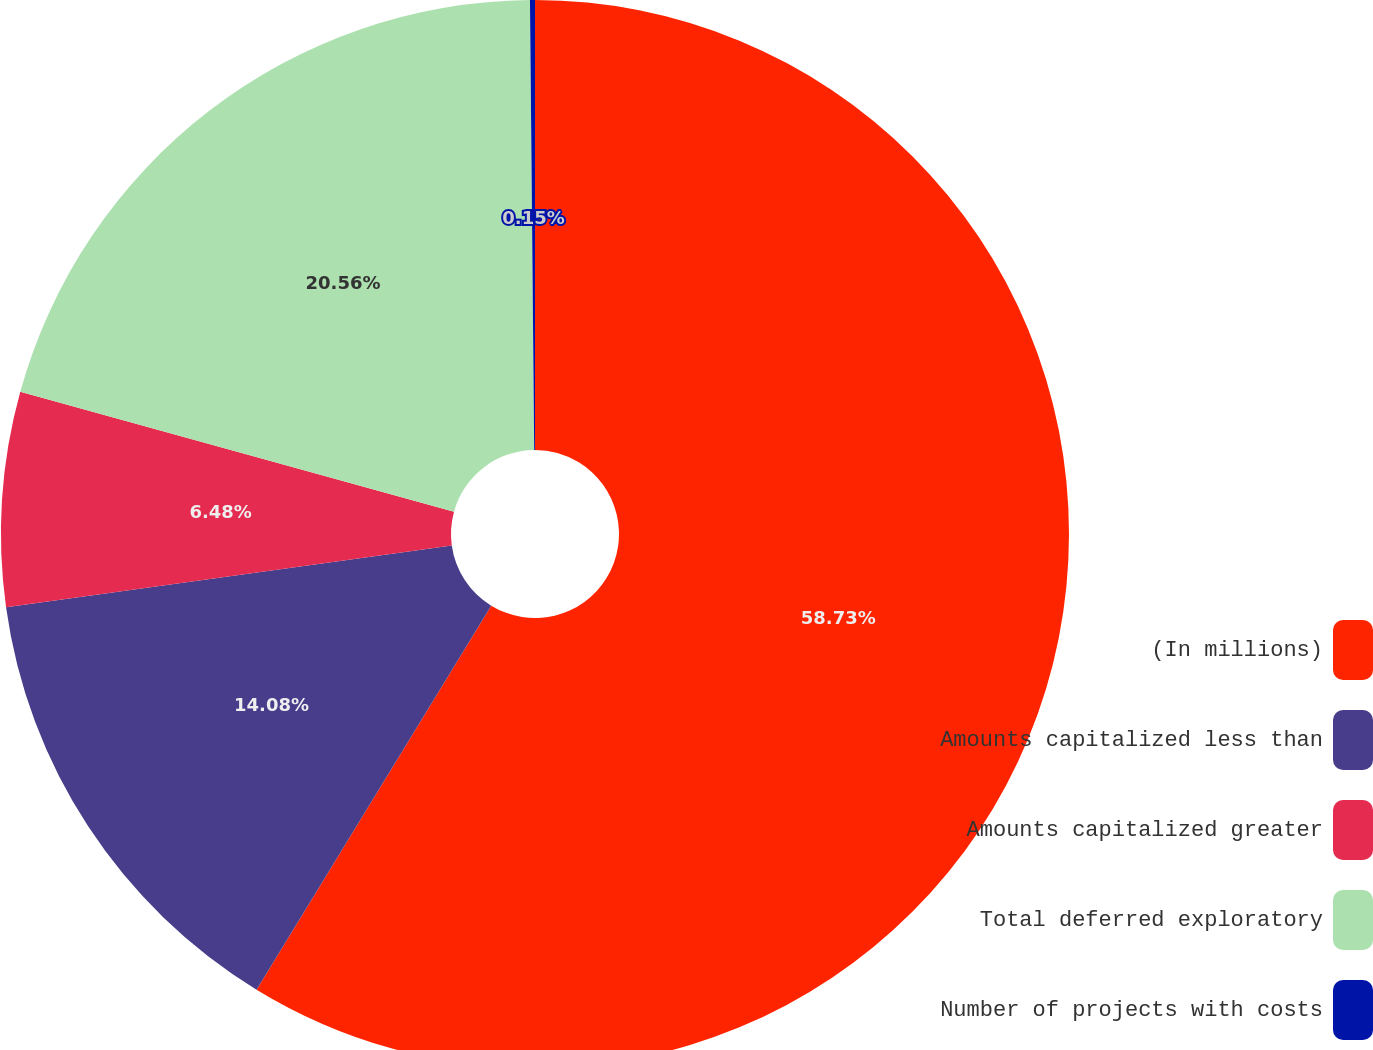Convert chart. <chart><loc_0><loc_0><loc_500><loc_500><pie_chart><fcel>(In millions)<fcel>Amounts capitalized less than<fcel>Amounts capitalized greater<fcel>Total deferred exploratory<fcel>Number of projects with costs<nl><fcel>58.73%<fcel>14.08%<fcel>6.48%<fcel>20.56%<fcel>0.15%<nl></chart> 